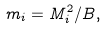Convert formula to latex. <formula><loc_0><loc_0><loc_500><loc_500>m _ { i } = M _ { i } ^ { 2 } / B ,</formula> 